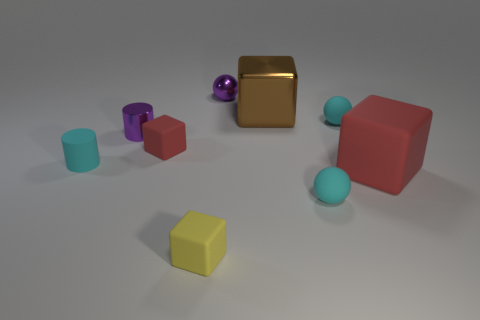Add 1 tiny red things. How many objects exist? 10 Subtract all blocks. How many objects are left? 5 Subtract 0 gray cylinders. How many objects are left? 9 Subtract all large rubber things. Subtract all purple metal cylinders. How many objects are left? 7 Add 1 yellow rubber cubes. How many yellow rubber cubes are left? 2 Add 2 tiny purple shiny objects. How many tiny purple shiny objects exist? 4 